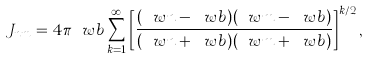Convert formula to latex. <formula><loc_0><loc_0><loc_500><loc_500>J _ { n m } = 4 \pi \ w b \sum _ { k = 1 } ^ { \infty } \left [ \frac { ( \ w n - \ w b ) ( \ w m - \ w b ) } { ( \ w n + \ w b ) ( \ w m + \ w b ) } \right ] ^ { k / 2 } ,</formula> 